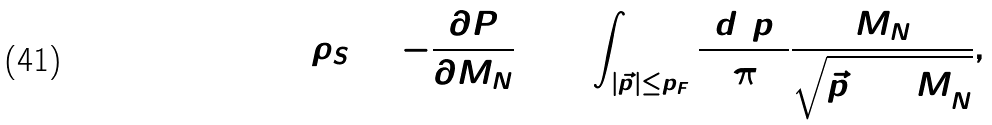Convert formula to latex. <formula><loc_0><loc_0><loc_500><loc_500>\rho _ { S } = - \frac { \partial P } { \partial M _ { N } } = 4 \int _ { | \vec { p } | \leq p _ { F } } \frac { d ^ { 3 } p } { ( 2 \pi ) ^ { 3 } } \frac { M _ { N } } { \sqrt { \vec { p } \, ^ { 2 } + M _ { N } ^ { 2 } } } ,</formula> 